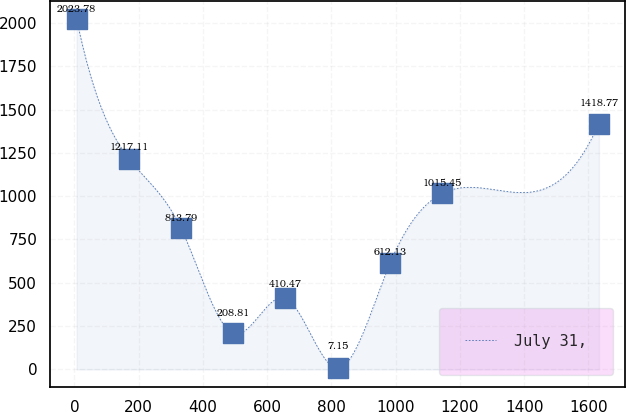<chart> <loc_0><loc_0><loc_500><loc_500><line_chart><ecel><fcel>July 31,<nl><fcel>6.68<fcel>2023.78<nl><fcel>169.26<fcel>1217.11<nl><fcel>331.84<fcel>813.79<nl><fcel>494.42<fcel>208.81<nl><fcel>657<fcel>410.47<nl><fcel>819.58<fcel>7.15<nl><fcel>982.16<fcel>612.13<nl><fcel>1144.74<fcel>1015.45<nl><fcel>1632.51<fcel>1418.77<nl></chart> 